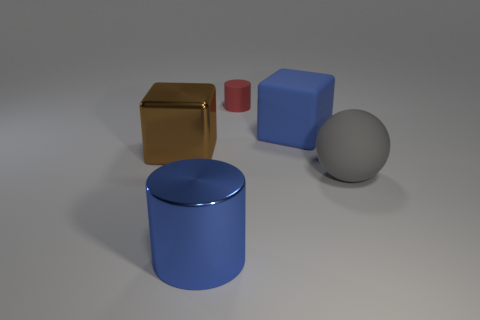Is there anything else that has the same color as the ball?
Offer a terse response. No. Do the metal cylinder and the brown shiny cube have the same size?
Ensure brevity in your answer.  Yes. There is a matte object that is on the left side of the big ball and in front of the red matte cylinder; how big is it?
Keep it short and to the point. Large. How many spheres have the same material as the tiny red cylinder?
Your answer should be compact. 1. There is a matte thing that is the same color as the metallic cylinder; what is its shape?
Offer a very short reply. Cube. What is the color of the rubber sphere?
Your answer should be compact. Gray. There is a shiny thing that is in front of the shiny block; is it the same shape as the big gray object?
Offer a very short reply. No. How many objects are either big blue things that are in front of the large blue cube or large blue metal things?
Offer a terse response. 1. Are there any big brown metallic things that have the same shape as the tiny thing?
Give a very brief answer. No. There is a matte thing that is the same size as the matte cube; what shape is it?
Offer a terse response. Sphere. 